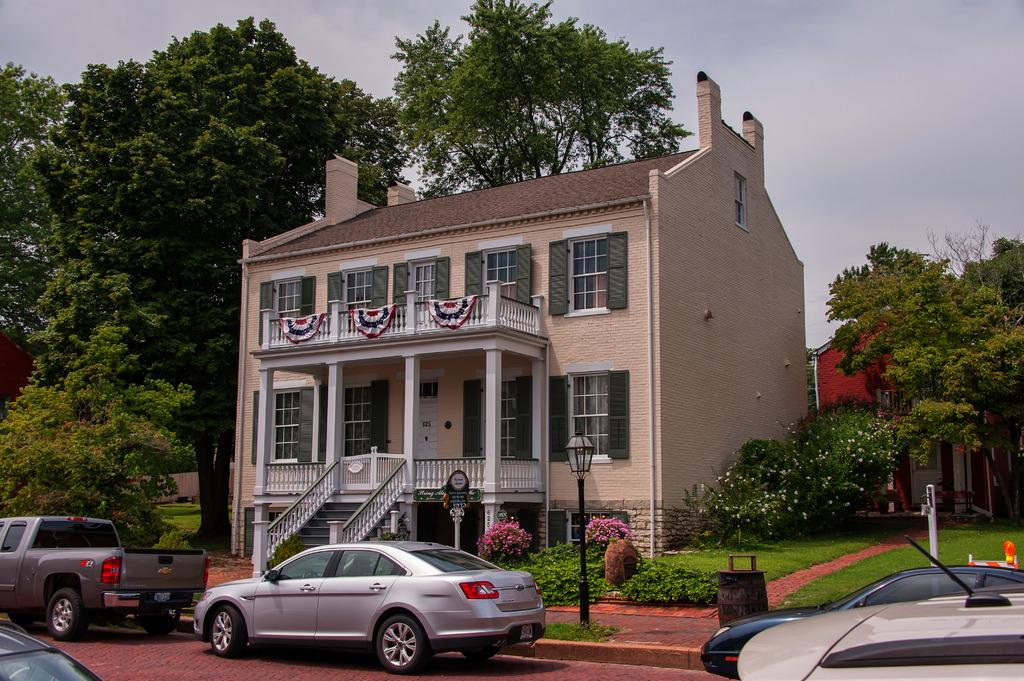What type of structures can be seen in the image? There are buildings in the image. What natural elements are present in the image? There are trees in the image. What type of vehicles can be seen in the image? Cars are visible in the image. What are the vertical structures in the image used for? There are poles in the image, which are likely used for supporting wires or signs. What type of plants are present in the image? Flowers are present in the image. What can be seen in the background of the image? The sky is visible in the background of the image. What is the learning process of the flowers in the image? The image does not depict a learning process for the flowers, as flowers do not have the ability to learn. How does the trick work with the cars in the image? There is no trick involving the cars in the image; they are simply parked or driving. 